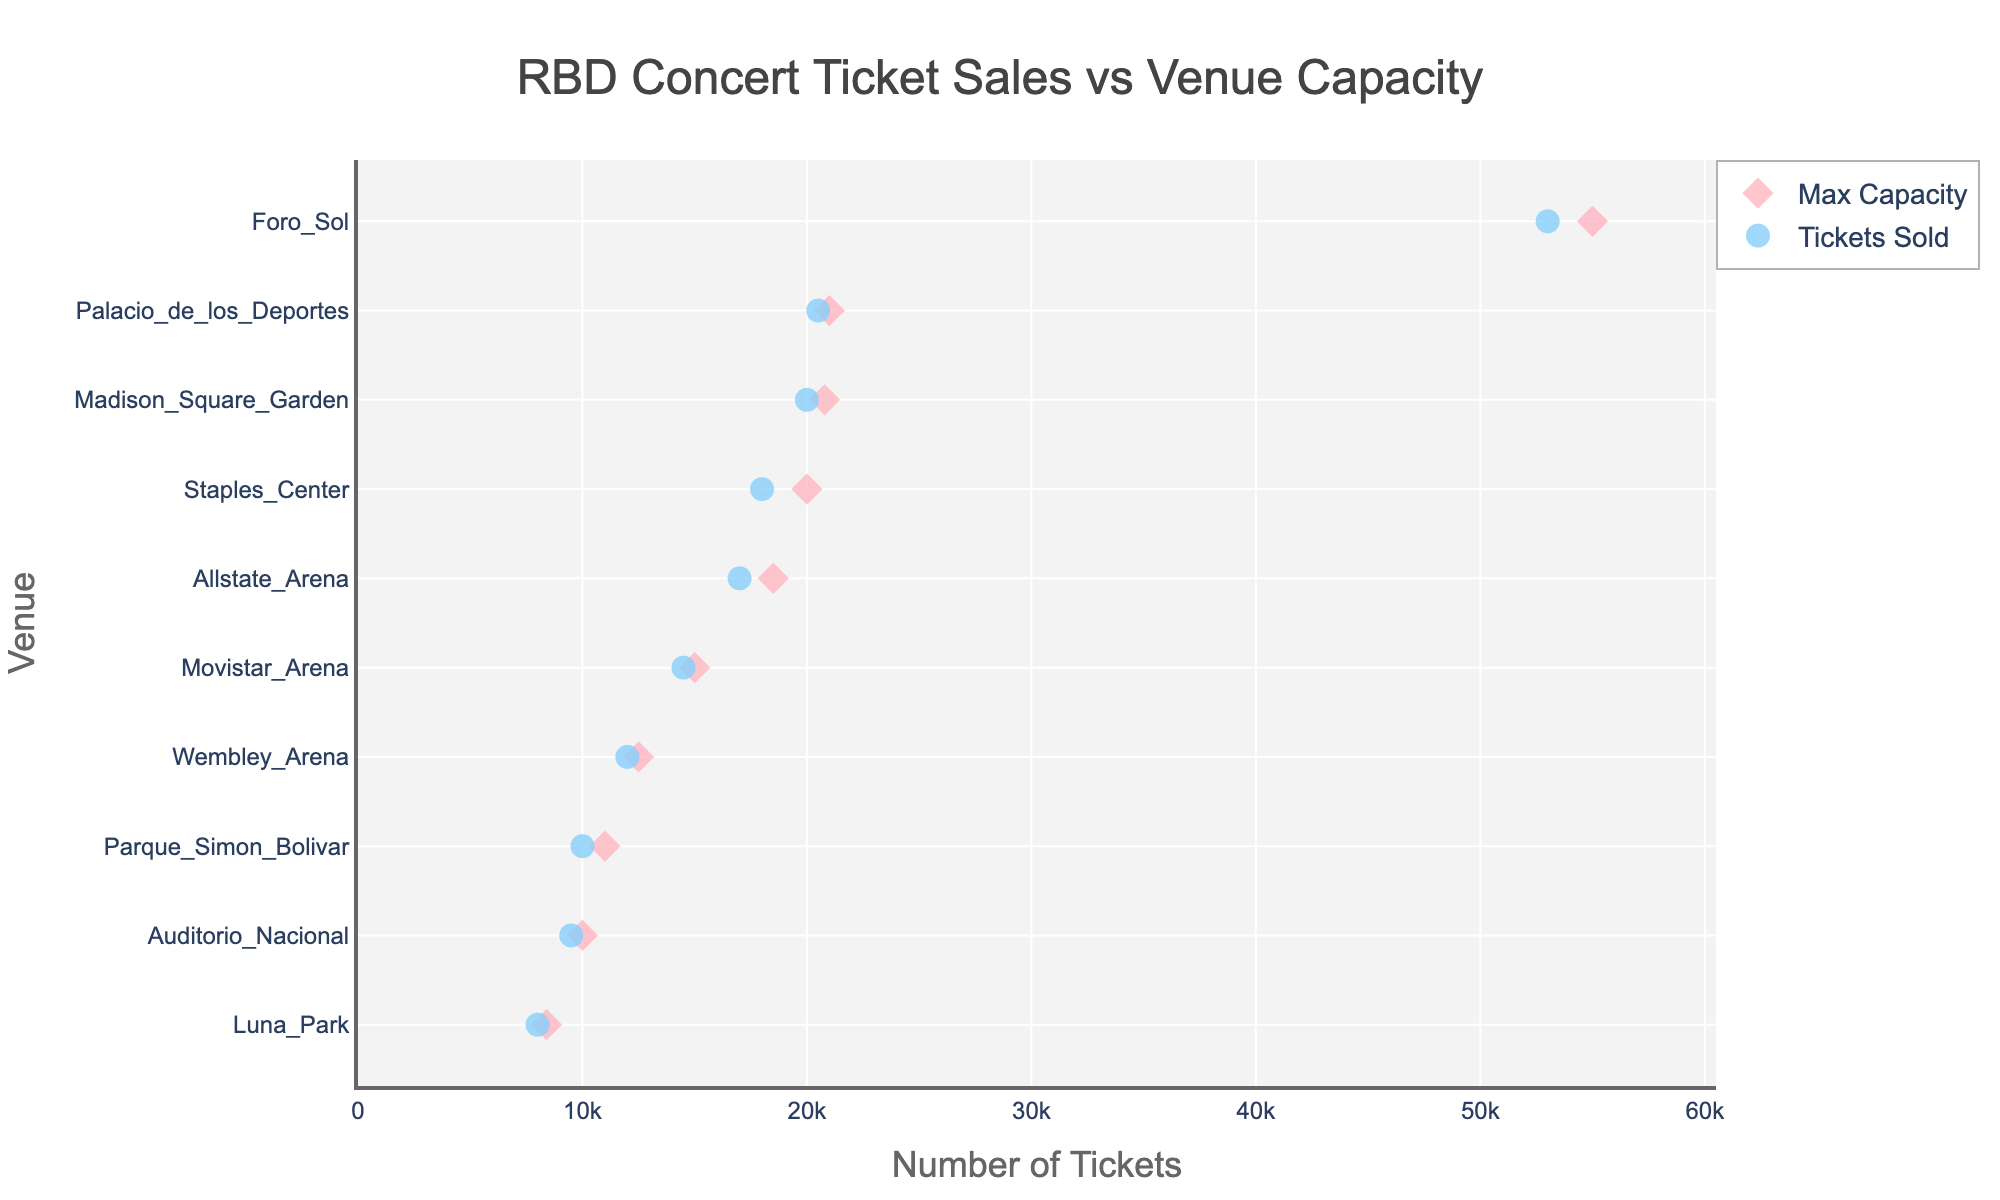Which venue has the highest maximum capacity? By looking at the figure, identify the marker corresponding to the highest point on the max capacity axis.
Answer: Foro Sol What is the difference between tickets sold and maximum capacity for Luna Park? Locate Luna Park on the Y-axis and note the values for both max capacity and tickets sold. Subtract tickets sold from max capacity (8400 - 8000).
Answer: 400 How many tickets did RBD sell for the concert at Madison Square Garden? Find Madison Square Garden on the Y-axis and check the associated value for tickets sold.
Answer: 20000 Which venue in Mexico City had the highest ticket sales? Identify the venues in Mexico City from the Y-axis and compare the ticket sales values for them.
Answer: Foro Sol Is there any venue where the tickets sold equaled the max capacity? Compare the values for tickets sold and max capacity for each venue to see if any are equal.
Answer: No Which venue has the smallest difference between tickets sold and maximum capacity? Calculate the difference between tickets sold and max capacity for each venue to find the smallest value.
Answer: Madison Square Garden What is the total number of tickets sold in all venues? Sum the ticket sales for all listed venues. (9500 + 18000 + 20000 + 53000 + 8000 + 14500 + 20500 + 17000 + 10000 + 12000)
Answer: 182500 Which city hosted the highest number of RBD concerts? Identify the cities from the Y-axis and count the number of venues in each city.
Answer: Mexico City By what percentage did tickets sold exceed the max capacity at Staples Center? Calculate the percentage using the formula ((tickets_sold - max_capacity) / max_capacity * 100). ((18000 - 20000) / 20000 * 100)
Answer: -10% What is the average number of tickets sold per venue? Sum the ticket sales for all venues and divide by the number of venues. (182500 / 10)
Answer: 18250 